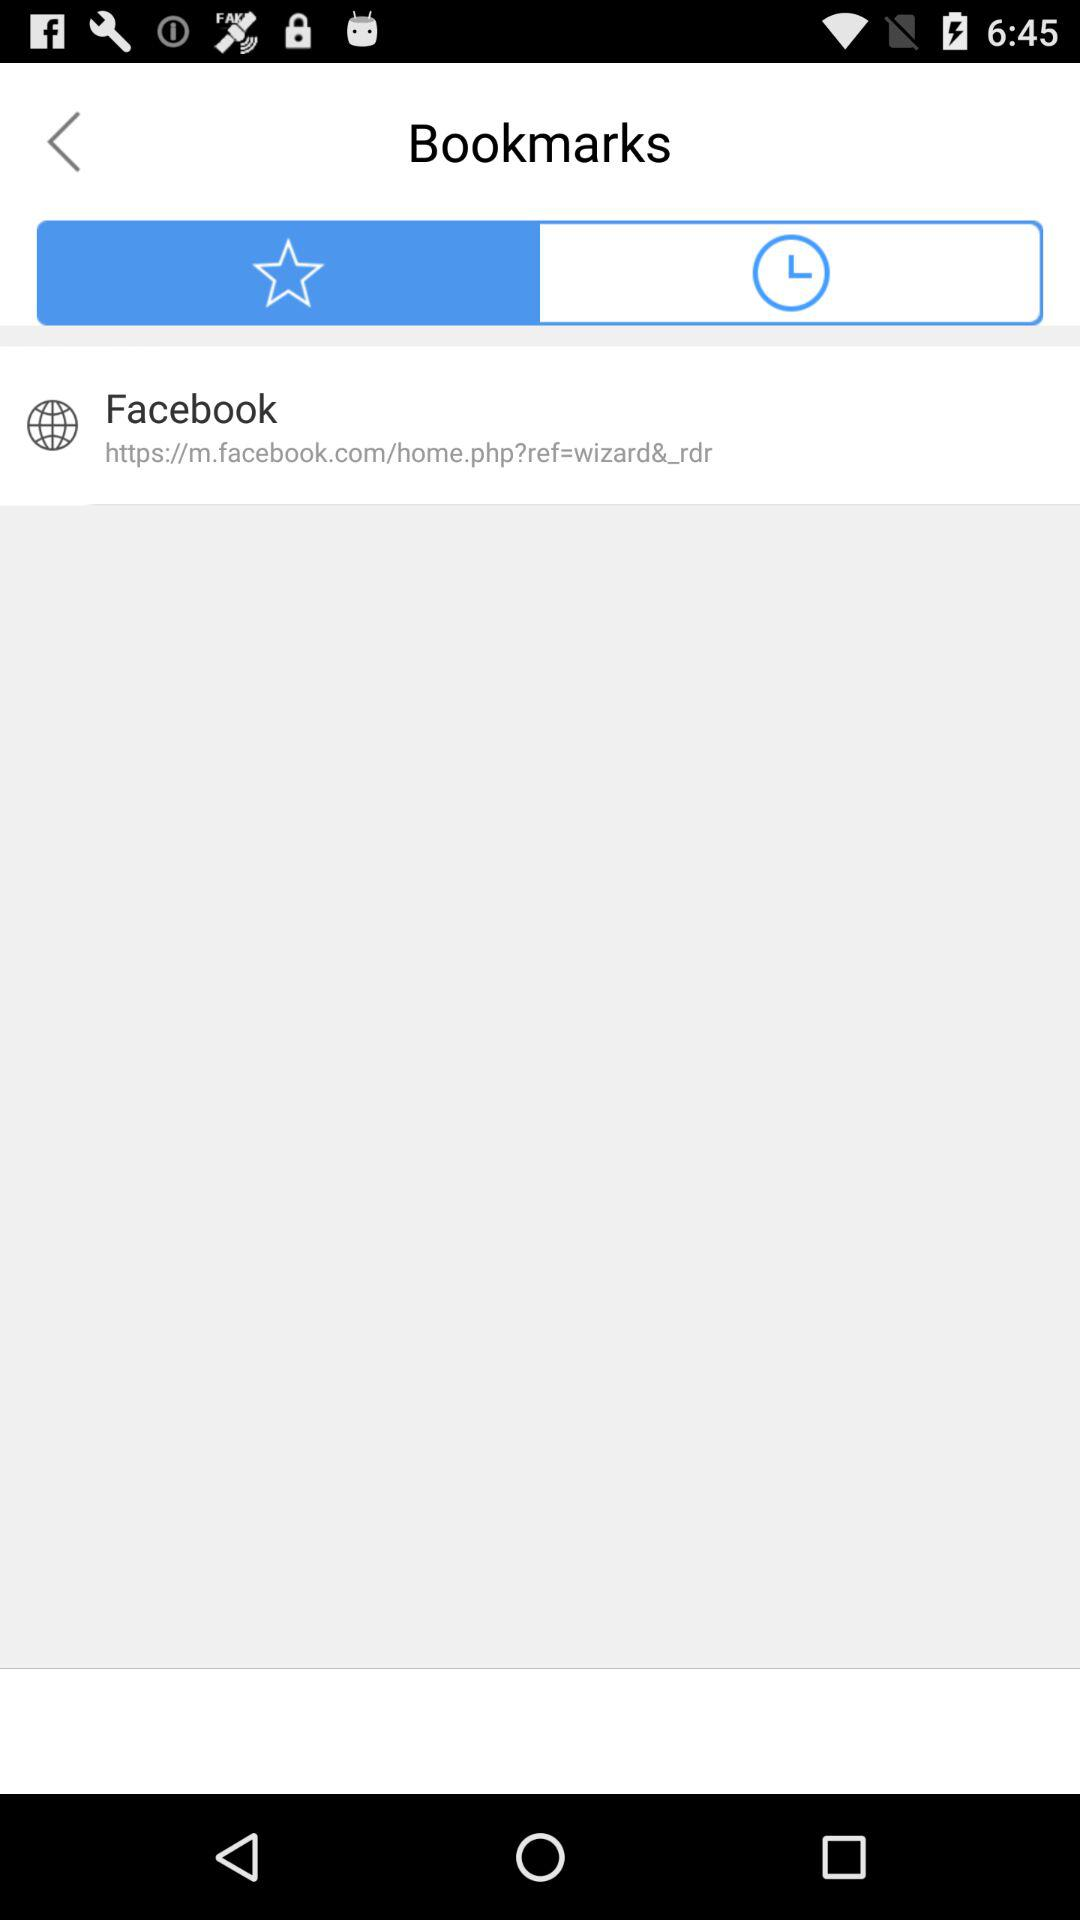What is saved in bookmark?
When the provided information is insufficient, respond with <no answer>. <no answer> 